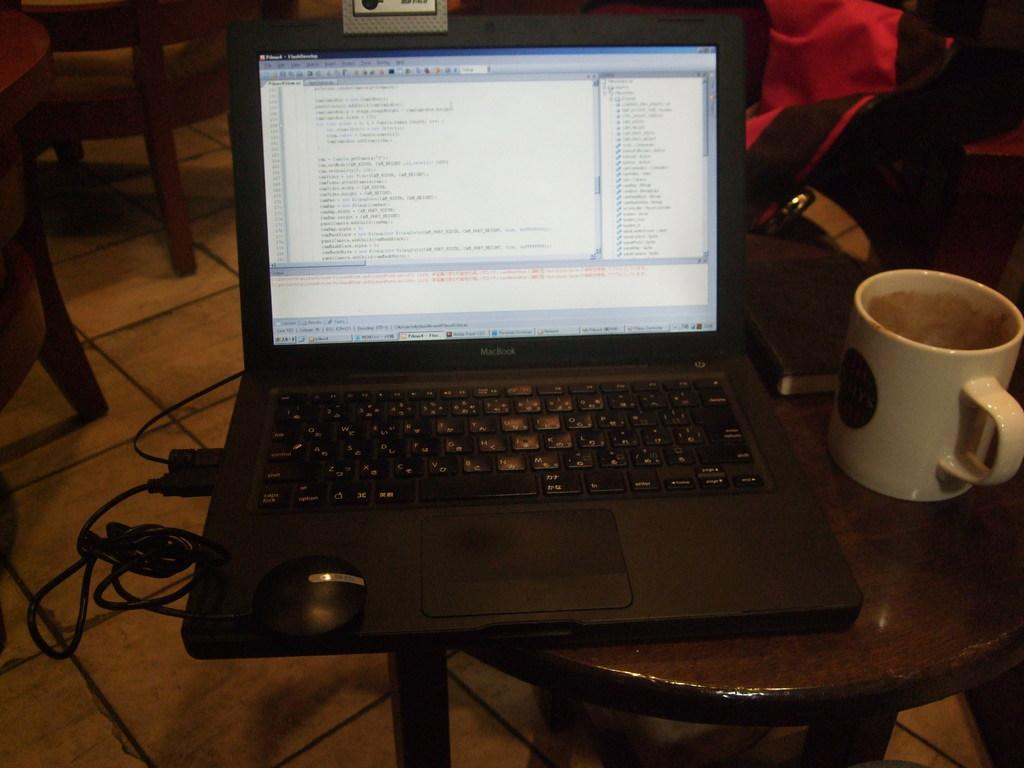What electronic device is on the table in the image? There is a laptop on the table in the image. Are there any accessories connected to the laptop? Yes, there are wires connected to the laptop. What is located beside the laptop? There is a cup beside the laptop. What can be seen in the background of the image? There is a bag in the background. What time of day is it in the image, given the angle of the sun? The angle of the sun is not visible in the image, so it cannot be determined what time of day it is. 